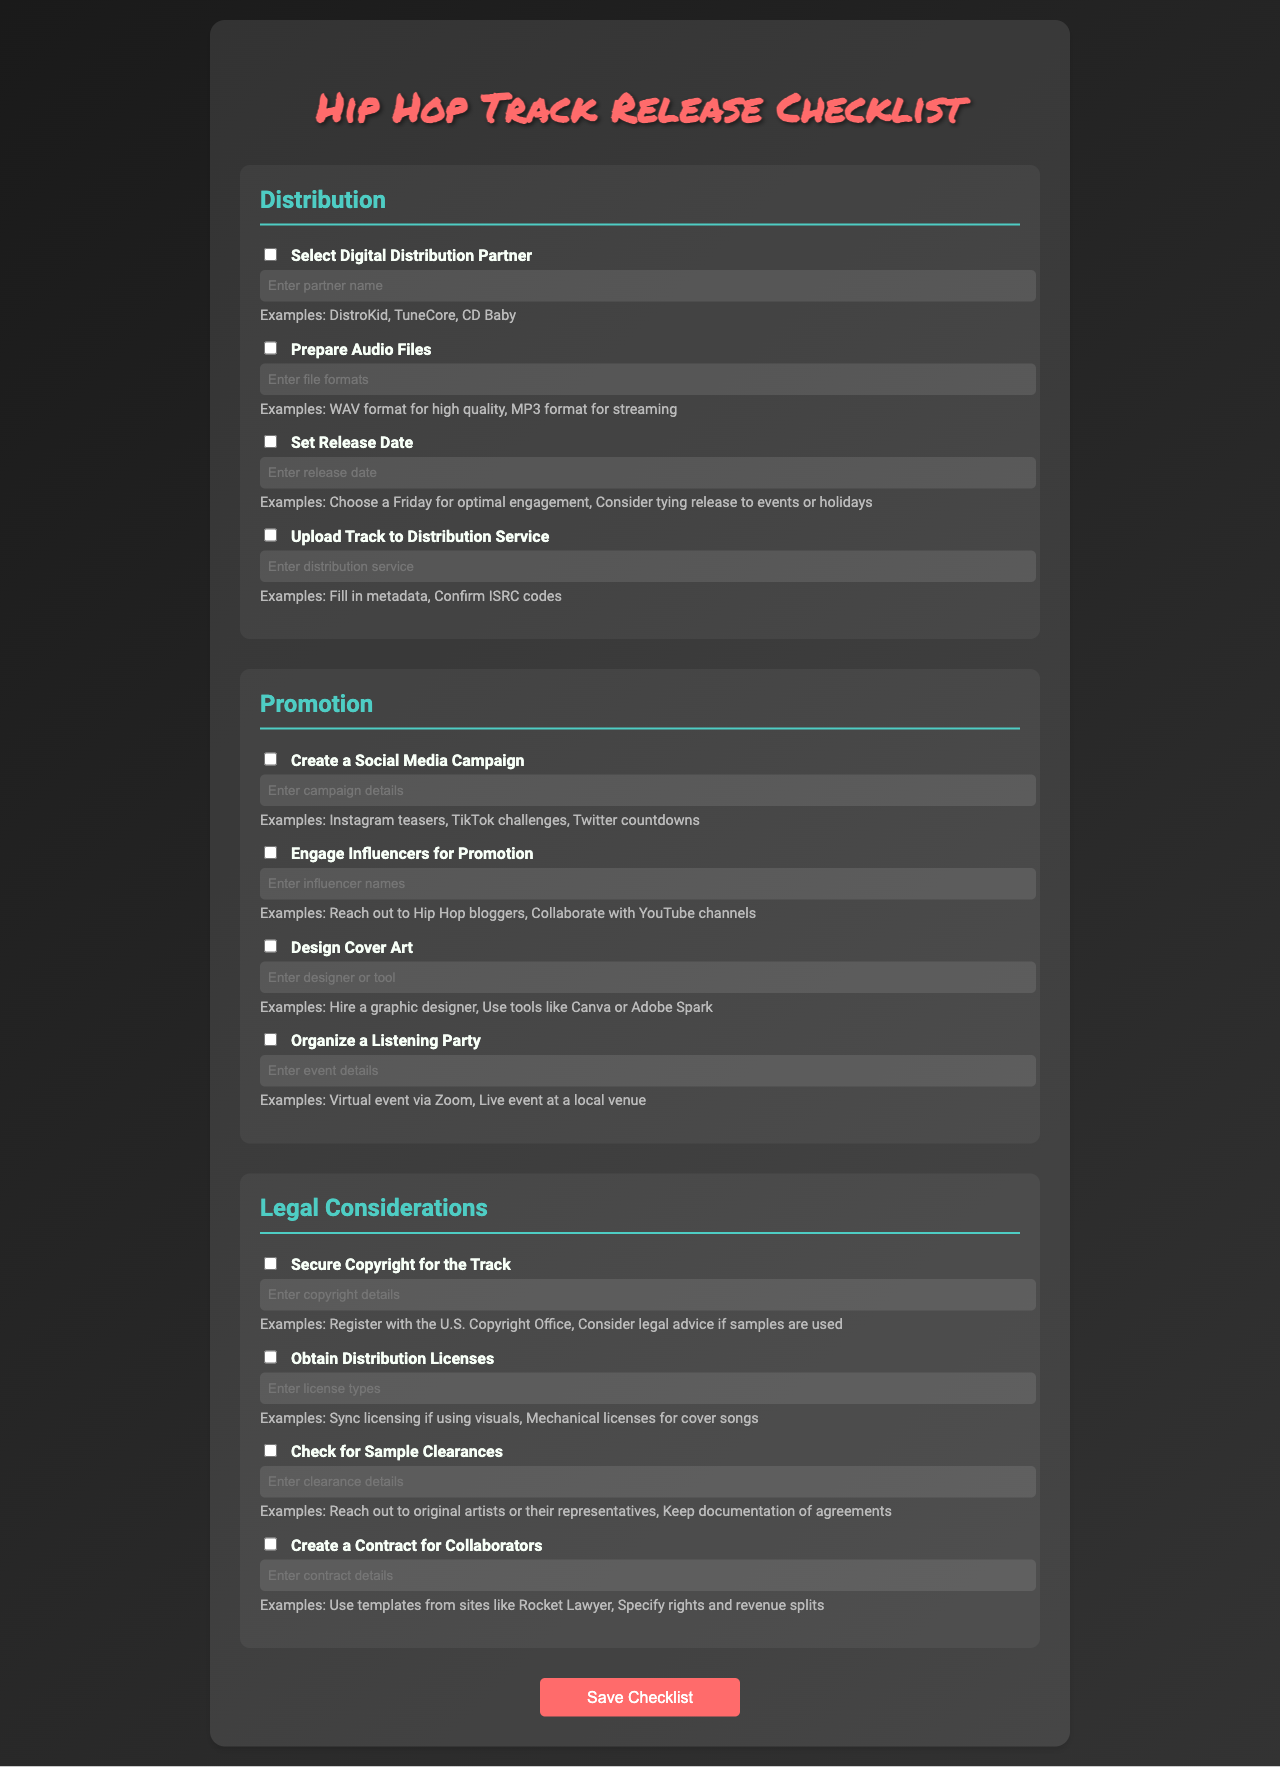what is the title of the document? The document has a title that describes the content, specifically related to the release of a hip hop track.
Answer: Hip Hop Track Release Checklist how many main categories are in the checklist? The checklist is divided into three main categories that organize the different tasks.
Answer: 3 what is one platform mentioned for digital distribution? The document provides examples of partners that could be selected for digital distribution within the checklist.
Answer: DistroKid what detail should you enter when setting the release date? When setting a release date, specific guidance is provided on the timing related to events for better engagement.
Answer: Enter release date name one action for promotion listed in the document. The document lists tasks for promoting the track which include various actions that can be taken to boost visibility.
Answer: Create a Social Media Campaign what type of licenses should be obtained? The document cites the necessity of securing licenses related to different types of music uses as part of the legal considerations.
Answer: Distribution Licenses what should be checked regarding samples? One of the legal considerations outlined includes a specific action to ensure compliance with other artists' works.
Answer: Sample Clearances who might you engage for promotion? The checklist suggests interacting with specific types of individuals who can help promote the track successfully.
Answer: Influencers what is mentioned about cover art? The document specifies a task that involves the design element of the release associated with visual branding.
Answer: Design Cover Art what type of party is suggested for the release? An event is proposed that allows fans and supporters to experience the track in a communal setting.
Answer: Listening Party 